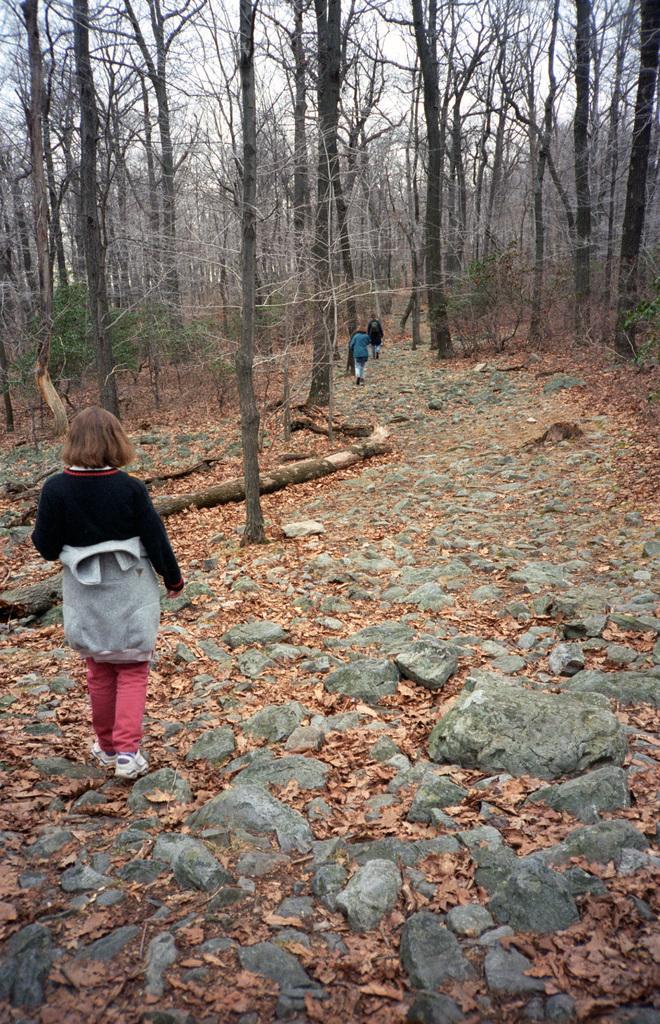Please provide a concise description of this image. In this image I can see the trees. In the background, I can see the sky. 